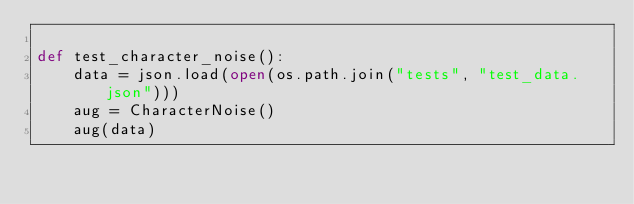<code> <loc_0><loc_0><loc_500><loc_500><_Python_>
def test_character_noise():
    data = json.load(open(os.path.join("tests", "test_data.json")))
    aug = CharacterNoise()
    aug(data)
</code> 